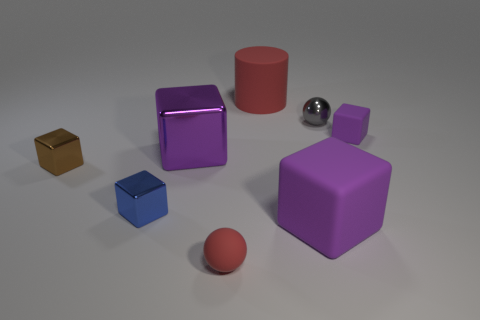What shape is the gray metallic object that is the same size as the brown metal thing?
Provide a succinct answer. Sphere. Is there a gray thing of the same shape as the brown thing?
Offer a terse response. No. Is the red cylinder made of the same material as the tiny object to the left of the blue metallic block?
Provide a short and direct response. No. There is a red thing that is on the left side of the large thing behind the tiny gray sphere; what is its material?
Make the answer very short. Rubber. Are there more small blue things to the left of the small brown block than large brown metallic blocks?
Keep it short and to the point. No. Is there a purple matte object?
Offer a terse response. Yes. The big thing behind the shiny ball is what color?
Keep it short and to the point. Red. There is a brown thing that is the same size as the rubber ball; what material is it?
Offer a terse response. Metal. There is a small shiny object that is right of the small brown metal block and on the left side of the tiny red matte sphere; what color is it?
Provide a short and direct response. Blue. How many objects are either large objects that are behind the large purple rubber cube or large brown cylinders?
Your answer should be compact. 2. 